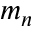<formula> <loc_0><loc_0><loc_500><loc_500>m _ { n }</formula> 